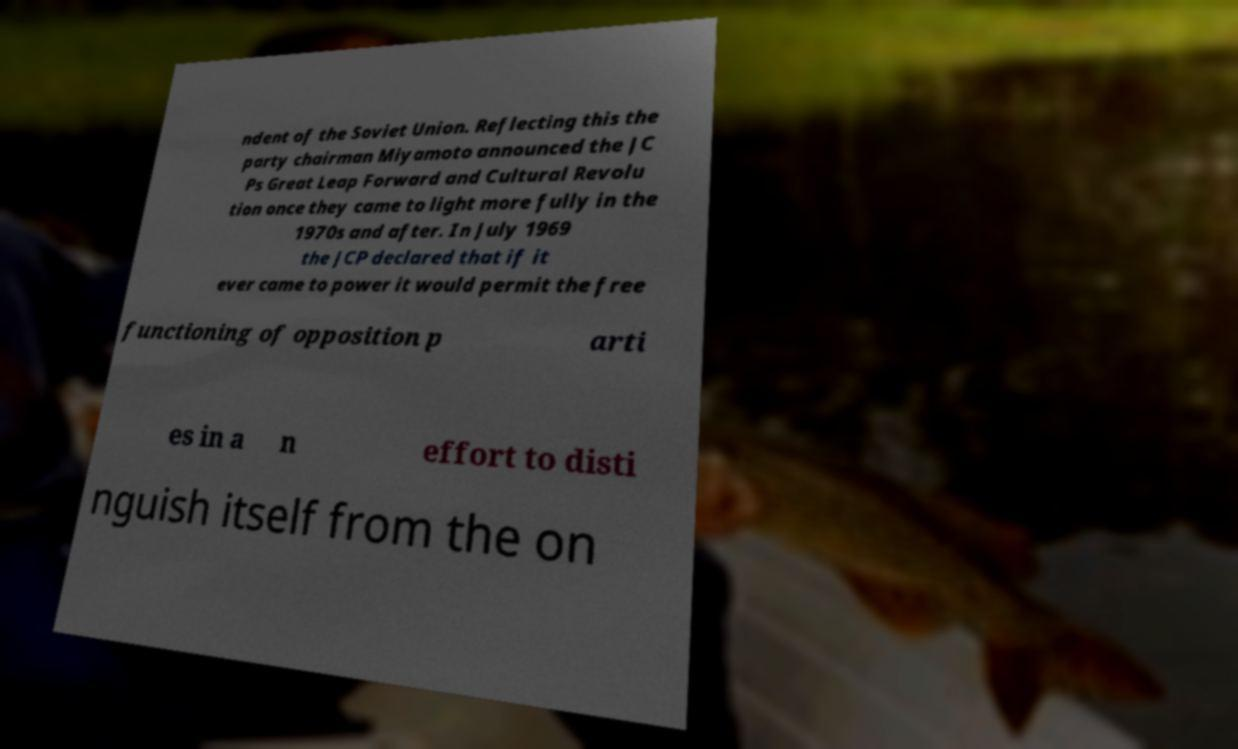Could you assist in decoding the text presented in this image and type it out clearly? ndent of the Soviet Union. Reflecting this the party chairman Miyamoto announced the JC Ps Great Leap Forward and Cultural Revolu tion once they came to light more fully in the 1970s and after. In July 1969 the JCP declared that if it ever came to power it would permit the free functioning of opposition p arti es in a n effort to disti nguish itself from the on 